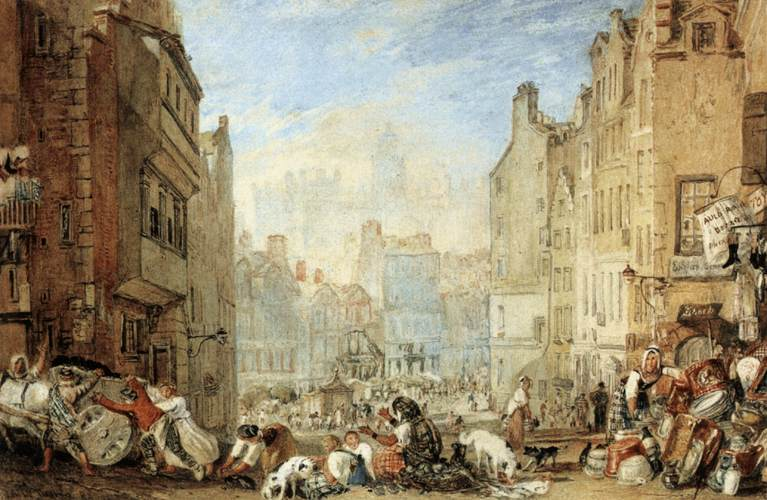Describe the following image. The image captures a lively street scene in what appears to be a European city, possibly during the 18th or 19th century. The foreground is populated with several figures engaged in various activities, from street vendors peddling their goods to children playing. There are also dogs among the people, adding to the hustle and bustle of the street. The buildings, constructed closely together, have a rustic charm with their weathered facades and intricate architectural details. The earthy tones of the buildings give a warm ambience, complemented by the clear blue sky above. The perspective draws the eye towards the background, which fades into a hazy depiction of more buildings and possibly a town square. The vivid depiction of daily life combines elements of landscape and genre painting, showcasing not only the architectural layout but also the social interactions of the time. 